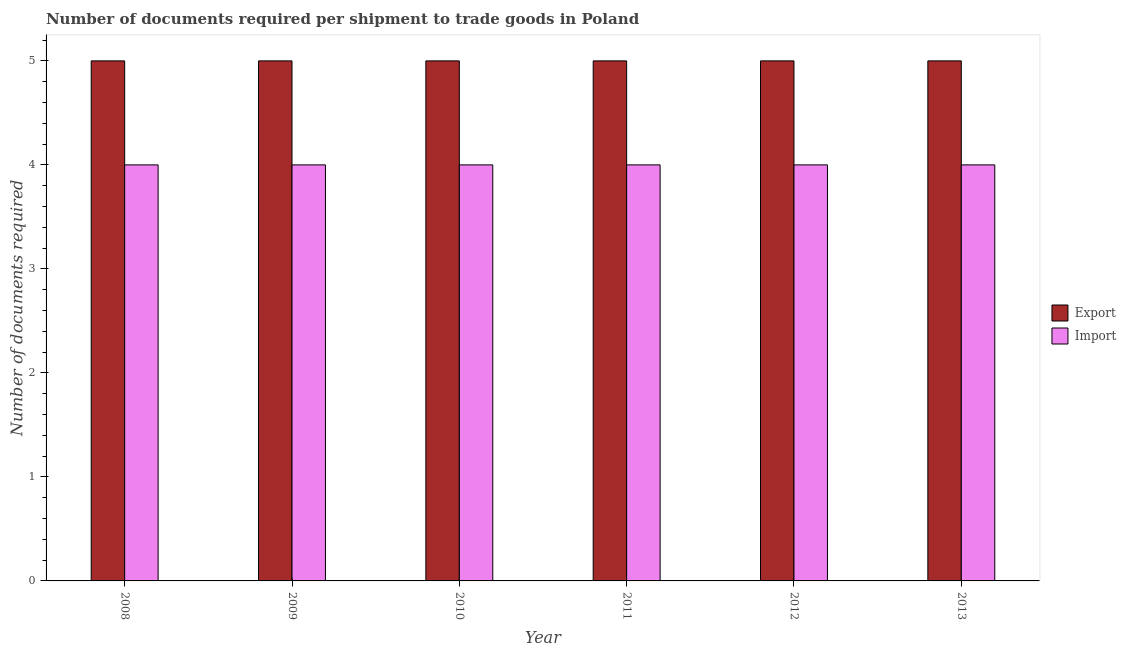How many different coloured bars are there?
Provide a succinct answer. 2. Are the number of bars per tick equal to the number of legend labels?
Give a very brief answer. Yes. How many bars are there on the 3rd tick from the left?
Give a very brief answer. 2. How many bars are there on the 2nd tick from the right?
Keep it short and to the point. 2. What is the label of the 4th group of bars from the left?
Your answer should be compact. 2011. In how many cases, is the number of bars for a given year not equal to the number of legend labels?
Keep it short and to the point. 0. What is the number of documents required to export goods in 2013?
Your answer should be compact. 5. Across all years, what is the maximum number of documents required to export goods?
Your answer should be very brief. 5. Across all years, what is the minimum number of documents required to export goods?
Provide a short and direct response. 5. In which year was the number of documents required to import goods maximum?
Provide a succinct answer. 2008. In which year was the number of documents required to import goods minimum?
Make the answer very short. 2008. What is the total number of documents required to import goods in the graph?
Offer a very short reply. 24. What is the difference between the number of documents required to export goods in 2012 and the number of documents required to import goods in 2008?
Provide a succinct answer. 0. Is the difference between the number of documents required to import goods in 2009 and 2010 greater than the difference between the number of documents required to export goods in 2009 and 2010?
Your answer should be compact. No. What is the difference between the highest and the second highest number of documents required to import goods?
Your response must be concise. 0. What does the 1st bar from the left in 2011 represents?
Offer a terse response. Export. What does the 2nd bar from the right in 2011 represents?
Provide a short and direct response. Export. How many years are there in the graph?
Your response must be concise. 6. What is the difference between two consecutive major ticks on the Y-axis?
Give a very brief answer. 1. Are the values on the major ticks of Y-axis written in scientific E-notation?
Offer a very short reply. No. Does the graph contain grids?
Your response must be concise. No. Where does the legend appear in the graph?
Your answer should be very brief. Center right. What is the title of the graph?
Offer a very short reply. Number of documents required per shipment to trade goods in Poland. What is the label or title of the X-axis?
Provide a succinct answer. Year. What is the label or title of the Y-axis?
Make the answer very short. Number of documents required. What is the Number of documents required in Export in 2010?
Your answer should be compact. 5. What is the Number of documents required in Import in 2010?
Provide a succinct answer. 4. What is the Number of documents required of Export in 2011?
Provide a short and direct response. 5. What is the Number of documents required in Export in 2013?
Your answer should be compact. 5. What is the Number of documents required in Import in 2013?
Make the answer very short. 4. Across all years, what is the minimum Number of documents required of Import?
Offer a terse response. 4. What is the total Number of documents required of Export in the graph?
Offer a very short reply. 30. What is the difference between the Number of documents required of Export in 2008 and that in 2009?
Provide a short and direct response. 0. What is the difference between the Number of documents required of Import in 2008 and that in 2009?
Provide a short and direct response. 0. What is the difference between the Number of documents required in Export in 2008 and that in 2011?
Offer a terse response. 0. What is the difference between the Number of documents required in Import in 2008 and that in 2011?
Your response must be concise. 0. What is the difference between the Number of documents required in Export in 2008 and that in 2012?
Your response must be concise. 0. What is the difference between the Number of documents required in Import in 2008 and that in 2013?
Ensure brevity in your answer.  0. What is the difference between the Number of documents required of Export in 2009 and that in 2011?
Offer a very short reply. 0. What is the difference between the Number of documents required in Import in 2009 and that in 2011?
Ensure brevity in your answer.  0. What is the difference between the Number of documents required in Export in 2009 and that in 2012?
Ensure brevity in your answer.  0. What is the difference between the Number of documents required of Import in 2010 and that in 2011?
Provide a short and direct response. 0. What is the difference between the Number of documents required of Export in 2010 and that in 2013?
Keep it short and to the point. 0. What is the difference between the Number of documents required of Import in 2010 and that in 2013?
Make the answer very short. 0. What is the difference between the Number of documents required of Export in 2011 and that in 2013?
Offer a terse response. 0. What is the difference between the Number of documents required of Import in 2011 and that in 2013?
Give a very brief answer. 0. What is the difference between the Number of documents required in Export in 2012 and that in 2013?
Your answer should be compact. 0. What is the difference between the Number of documents required in Import in 2012 and that in 2013?
Keep it short and to the point. 0. What is the difference between the Number of documents required in Export in 2008 and the Number of documents required in Import in 2009?
Your response must be concise. 1. What is the difference between the Number of documents required in Export in 2008 and the Number of documents required in Import in 2010?
Ensure brevity in your answer.  1. What is the difference between the Number of documents required of Export in 2008 and the Number of documents required of Import in 2011?
Your answer should be very brief. 1. What is the difference between the Number of documents required in Export in 2008 and the Number of documents required in Import in 2012?
Offer a very short reply. 1. What is the difference between the Number of documents required of Export in 2009 and the Number of documents required of Import in 2011?
Provide a succinct answer. 1. What is the difference between the Number of documents required of Export in 2009 and the Number of documents required of Import in 2013?
Offer a very short reply. 1. What is the difference between the Number of documents required in Export in 2010 and the Number of documents required in Import in 2011?
Ensure brevity in your answer.  1. What is the difference between the Number of documents required of Export in 2011 and the Number of documents required of Import in 2012?
Ensure brevity in your answer.  1. What is the difference between the Number of documents required in Export in 2011 and the Number of documents required in Import in 2013?
Provide a succinct answer. 1. What is the average Number of documents required in Export per year?
Keep it short and to the point. 5. In the year 2008, what is the difference between the Number of documents required of Export and Number of documents required of Import?
Offer a terse response. 1. In the year 2009, what is the difference between the Number of documents required in Export and Number of documents required in Import?
Offer a very short reply. 1. In the year 2010, what is the difference between the Number of documents required of Export and Number of documents required of Import?
Provide a short and direct response. 1. In the year 2011, what is the difference between the Number of documents required of Export and Number of documents required of Import?
Your response must be concise. 1. In the year 2012, what is the difference between the Number of documents required in Export and Number of documents required in Import?
Ensure brevity in your answer.  1. What is the ratio of the Number of documents required in Export in 2008 to that in 2010?
Your response must be concise. 1. What is the ratio of the Number of documents required in Export in 2008 to that in 2011?
Offer a terse response. 1. What is the ratio of the Number of documents required in Export in 2008 to that in 2012?
Keep it short and to the point. 1. What is the ratio of the Number of documents required of Import in 2008 to that in 2012?
Offer a very short reply. 1. What is the ratio of the Number of documents required of Export in 2008 to that in 2013?
Provide a short and direct response. 1. What is the ratio of the Number of documents required of Import in 2008 to that in 2013?
Keep it short and to the point. 1. What is the ratio of the Number of documents required of Export in 2009 to that in 2010?
Keep it short and to the point. 1. What is the ratio of the Number of documents required of Import in 2009 to that in 2013?
Provide a succinct answer. 1. What is the ratio of the Number of documents required of Export in 2010 to that in 2011?
Provide a short and direct response. 1. What is the ratio of the Number of documents required of Import in 2011 to that in 2012?
Your answer should be compact. 1. What is the ratio of the Number of documents required in Export in 2011 to that in 2013?
Offer a terse response. 1. What is the difference between the highest and the second highest Number of documents required of Export?
Your answer should be very brief. 0. What is the difference between the highest and the second highest Number of documents required in Import?
Give a very brief answer. 0. What is the difference between the highest and the lowest Number of documents required in Import?
Your answer should be very brief. 0. 